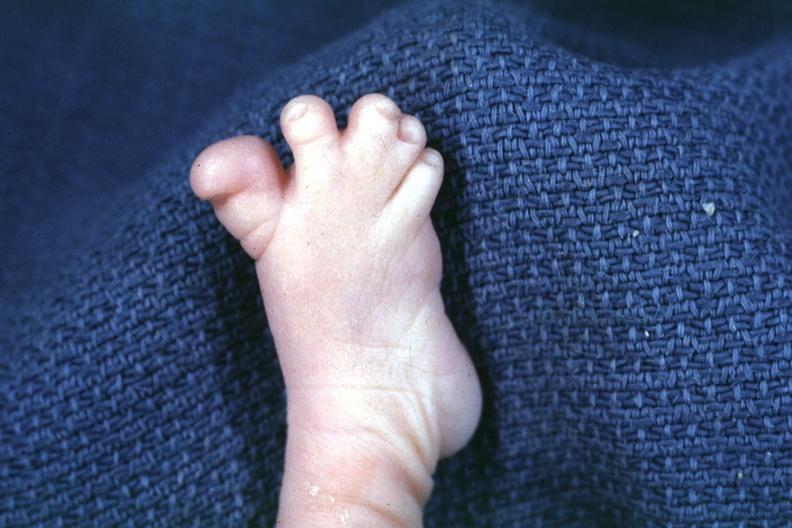re extremities present?
Answer the question using a single word or phrase. Yes 